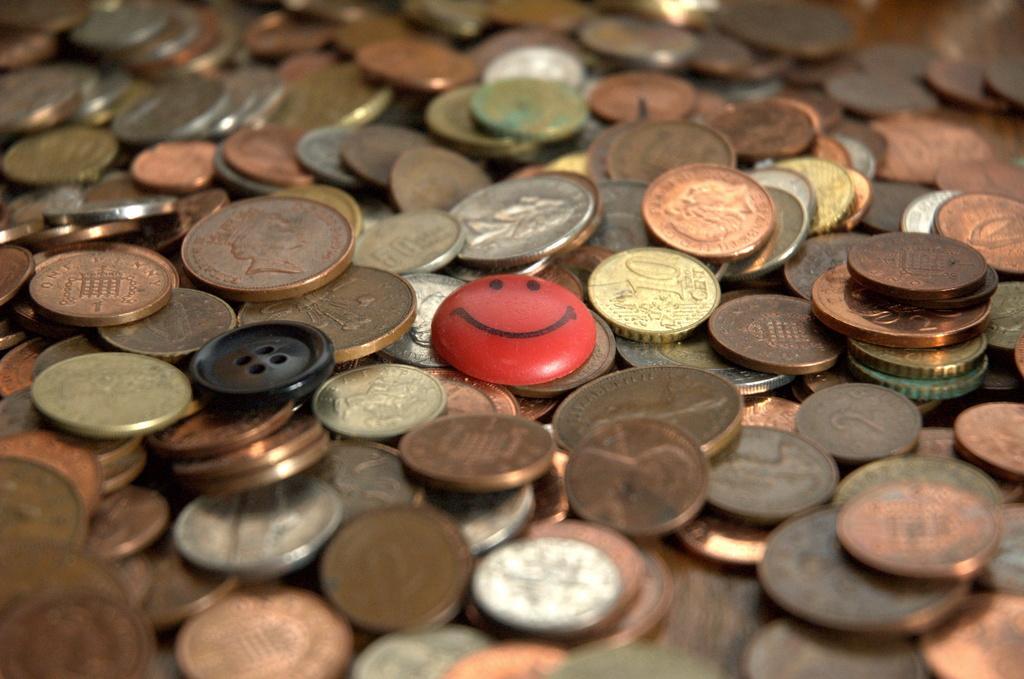How would you summarize this image in a sentence or two? In this picture we can see a group of coins,smiley badge on a platform. 